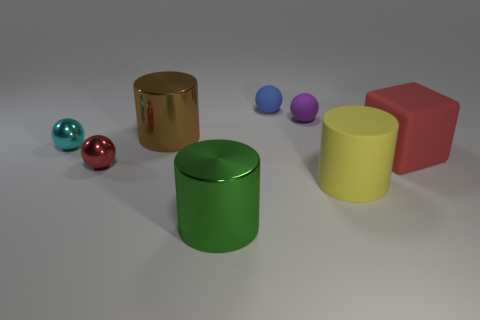Subtract all big brown cylinders. How many cylinders are left? 2 Subtract 1 balls. How many balls are left? 3 Add 1 tiny red shiny things. How many objects exist? 9 Subtract 1 yellow cylinders. How many objects are left? 7 Subtract all cylinders. How many objects are left? 5 Subtract all red balls. Subtract all yellow cubes. How many balls are left? 3 Subtract all red balls. How many gray blocks are left? 0 Subtract all large cyan matte spheres. Subtract all small matte balls. How many objects are left? 6 Add 5 big red objects. How many big red objects are left? 6 Add 7 large rubber blocks. How many large rubber blocks exist? 8 